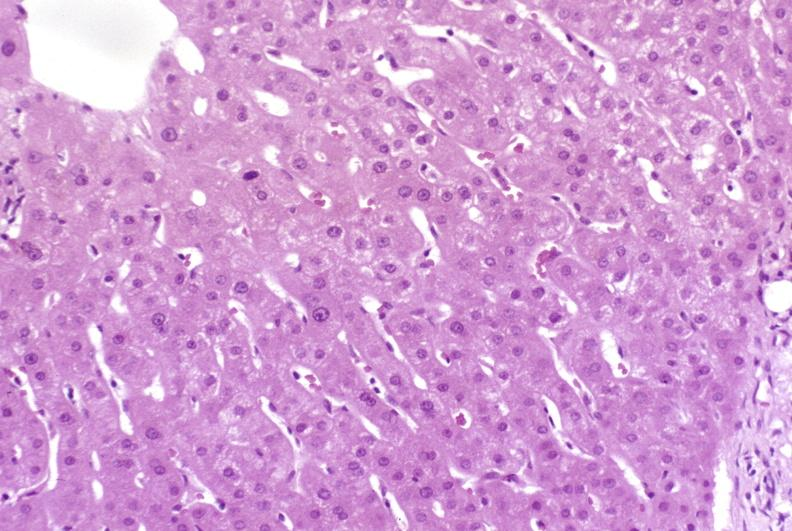s hepatobiliary present?
Answer the question using a single word or phrase. Yes 